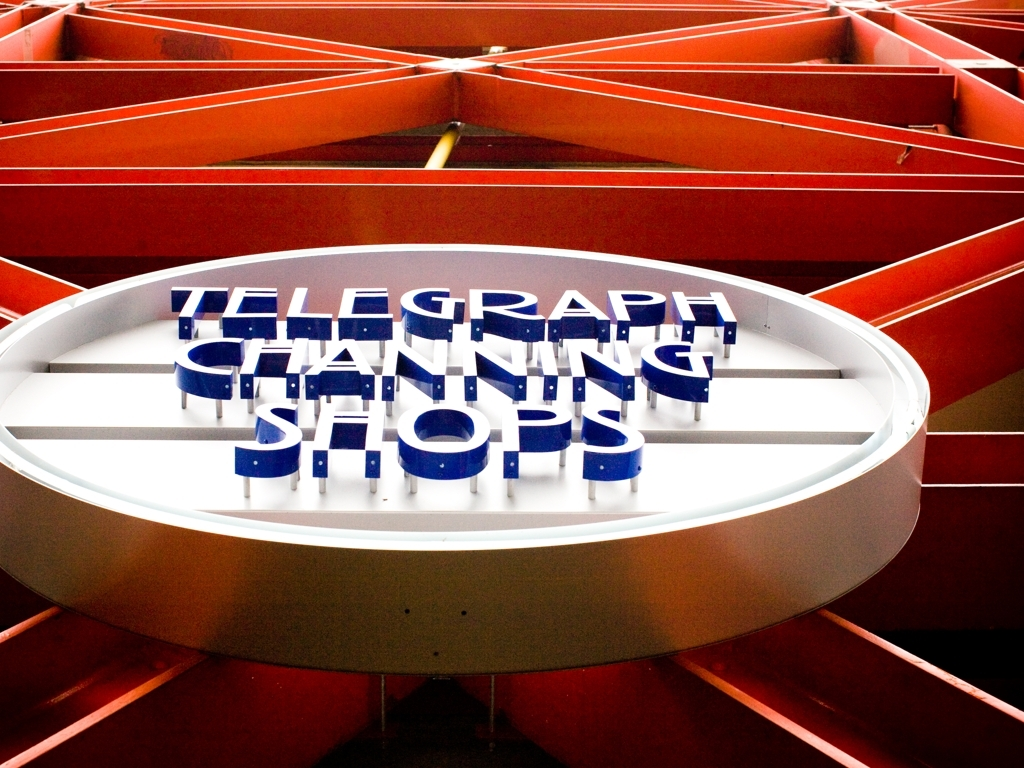What can we conclude about the image quality? While the response chose option A, indicating that it is a high-quality image, we could certainly elaborate that the image has vibrant colors and sharp details, which are indicative of a higher-resolution capture. However, the quality is not necessarily 'exceptional' since there are signs of overexposure, particularly in the highlight areas, and there may be room for improvement in dynamic range and noise levels. 